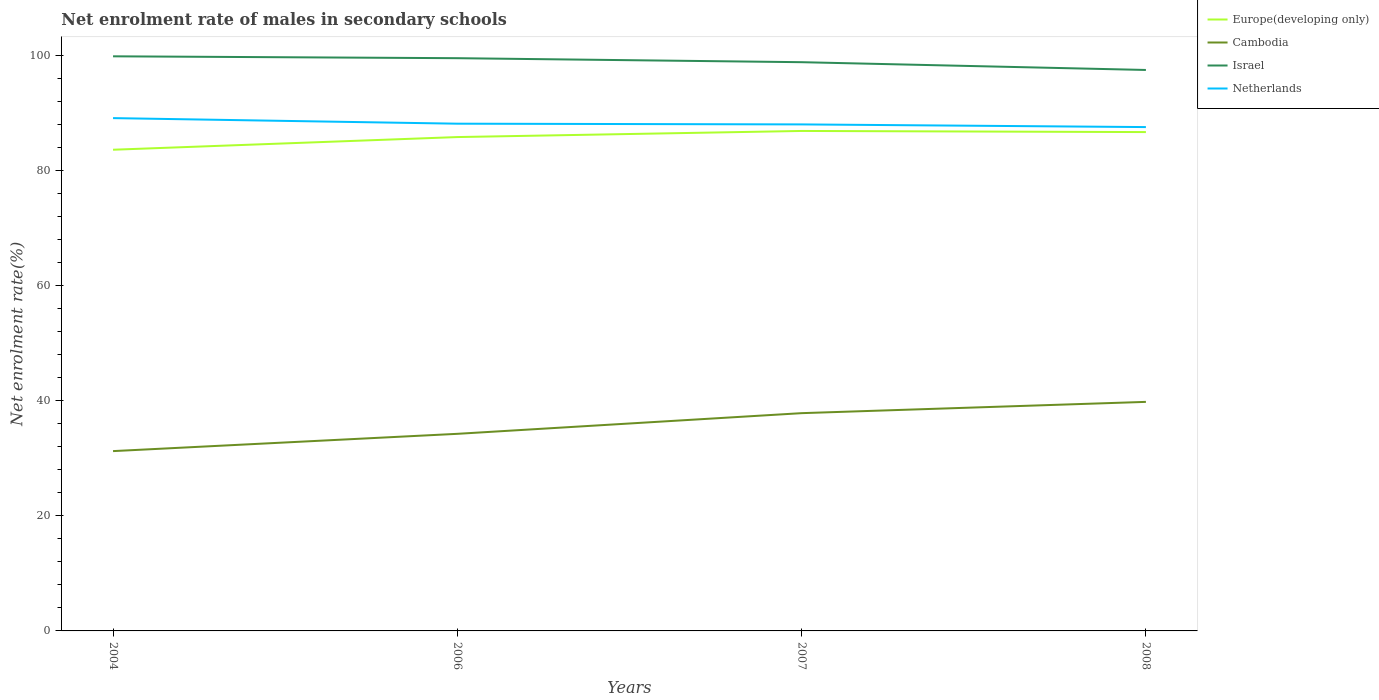How many different coloured lines are there?
Give a very brief answer. 4. Does the line corresponding to Israel intersect with the line corresponding to Europe(developing only)?
Your response must be concise. No. Is the number of lines equal to the number of legend labels?
Give a very brief answer. Yes. Across all years, what is the maximum net enrolment rate of males in secondary schools in Cambodia?
Your answer should be very brief. 31.24. In which year was the net enrolment rate of males in secondary schools in Netherlands maximum?
Offer a very short reply. 2008. What is the total net enrolment rate of males in secondary schools in Europe(developing only) in the graph?
Ensure brevity in your answer.  -1.06. What is the difference between the highest and the second highest net enrolment rate of males in secondary schools in Cambodia?
Keep it short and to the point. 8.55. Is the net enrolment rate of males in secondary schools in Europe(developing only) strictly greater than the net enrolment rate of males in secondary schools in Israel over the years?
Give a very brief answer. Yes. How many lines are there?
Keep it short and to the point. 4. How many years are there in the graph?
Offer a very short reply. 4. What is the difference between two consecutive major ticks on the Y-axis?
Offer a very short reply. 20. Are the values on the major ticks of Y-axis written in scientific E-notation?
Your answer should be compact. No. Does the graph contain grids?
Offer a terse response. No. Where does the legend appear in the graph?
Your answer should be very brief. Top right. How many legend labels are there?
Offer a terse response. 4. How are the legend labels stacked?
Provide a succinct answer. Vertical. What is the title of the graph?
Provide a succinct answer. Net enrolment rate of males in secondary schools. Does "Northern Mariana Islands" appear as one of the legend labels in the graph?
Your response must be concise. No. What is the label or title of the X-axis?
Provide a succinct answer. Years. What is the label or title of the Y-axis?
Your response must be concise. Net enrolment rate(%). What is the Net enrolment rate(%) of Europe(developing only) in 2004?
Make the answer very short. 83.59. What is the Net enrolment rate(%) of Cambodia in 2004?
Make the answer very short. 31.24. What is the Net enrolment rate(%) in Israel in 2004?
Your answer should be compact. 99.82. What is the Net enrolment rate(%) of Netherlands in 2004?
Your response must be concise. 89.09. What is the Net enrolment rate(%) of Europe(developing only) in 2006?
Your answer should be compact. 85.79. What is the Net enrolment rate(%) of Cambodia in 2006?
Your answer should be very brief. 34.24. What is the Net enrolment rate(%) in Israel in 2006?
Keep it short and to the point. 99.5. What is the Net enrolment rate(%) in Netherlands in 2006?
Your answer should be very brief. 88.12. What is the Net enrolment rate(%) of Europe(developing only) in 2007?
Give a very brief answer. 86.86. What is the Net enrolment rate(%) of Cambodia in 2007?
Offer a very short reply. 37.83. What is the Net enrolment rate(%) of Israel in 2007?
Make the answer very short. 98.8. What is the Net enrolment rate(%) in Netherlands in 2007?
Ensure brevity in your answer.  87.99. What is the Net enrolment rate(%) in Europe(developing only) in 2008?
Keep it short and to the point. 86.66. What is the Net enrolment rate(%) in Cambodia in 2008?
Give a very brief answer. 39.79. What is the Net enrolment rate(%) of Israel in 2008?
Provide a succinct answer. 97.45. What is the Net enrolment rate(%) of Netherlands in 2008?
Your answer should be very brief. 87.53. Across all years, what is the maximum Net enrolment rate(%) in Europe(developing only)?
Provide a short and direct response. 86.86. Across all years, what is the maximum Net enrolment rate(%) in Cambodia?
Make the answer very short. 39.79. Across all years, what is the maximum Net enrolment rate(%) in Israel?
Your answer should be very brief. 99.82. Across all years, what is the maximum Net enrolment rate(%) in Netherlands?
Your answer should be compact. 89.09. Across all years, what is the minimum Net enrolment rate(%) in Europe(developing only)?
Make the answer very short. 83.59. Across all years, what is the minimum Net enrolment rate(%) of Cambodia?
Your answer should be compact. 31.24. Across all years, what is the minimum Net enrolment rate(%) in Israel?
Your answer should be very brief. 97.45. Across all years, what is the minimum Net enrolment rate(%) of Netherlands?
Offer a very short reply. 87.53. What is the total Net enrolment rate(%) of Europe(developing only) in the graph?
Your response must be concise. 342.9. What is the total Net enrolment rate(%) in Cambodia in the graph?
Your answer should be very brief. 143.1. What is the total Net enrolment rate(%) of Israel in the graph?
Keep it short and to the point. 395.57. What is the total Net enrolment rate(%) in Netherlands in the graph?
Your answer should be very brief. 352.73. What is the difference between the Net enrolment rate(%) in Europe(developing only) in 2004 and that in 2006?
Give a very brief answer. -2.2. What is the difference between the Net enrolment rate(%) of Cambodia in 2004 and that in 2006?
Your answer should be compact. -3. What is the difference between the Net enrolment rate(%) in Israel in 2004 and that in 2006?
Your response must be concise. 0.33. What is the difference between the Net enrolment rate(%) of Netherlands in 2004 and that in 2006?
Ensure brevity in your answer.  0.97. What is the difference between the Net enrolment rate(%) in Europe(developing only) in 2004 and that in 2007?
Make the answer very short. -3.26. What is the difference between the Net enrolment rate(%) in Cambodia in 2004 and that in 2007?
Provide a succinct answer. -6.59. What is the difference between the Net enrolment rate(%) in Israel in 2004 and that in 2007?
Give a very brief answer. 1.02. What is the difference between the Net enrolment rate(%) of Netherlands in 2004 and that in 2007?
Offer a very short reply. 1.09. What is the difference between the Net enrolment rate(%) of Europe(developing only) in 2004 and that in 2008?
Offer a terse response. -3.07. What is the difference between the Net enrolment rate(%) in Cambodia in 2004 and that in 2008?
Your answer should be very brief. -8.55. What is the difference between the Net enrolment rate(%) of Israel in 2004 and that in 2008?
Offer a terse response. 2.37. What is the difference between the Net enrolment rate(%) of Netherlands in 2004 and that in 2008?
Keep it short and to the point. 1.56. What is the difference between the Net enrolment rate(%) in Europe(developing only) in 2006 and that in 2007?
Give a very brief answer. -1.06. What is the difference between the Net enrolment rate(%) of Cambodia in 2006 and that in 2007?
Offer a very short reply. -3.59. What is the difference between the Net enrolment rate(%) in Israel in 2006 and that in 2007?
Your answer should be very brief. 0.7. What is the difference between the Net enrolment rate(%) of Netherlands in 2006 and that in 2007?
Your response must be concise. 0.13. What is the difference between the Net enrolment rate(%) of Europe(developing only) in 2006 and that in 2008?
Provide a succinct answer. -0.86. What is the difference between the Net enrolment rate(%) of Cambodia in 2006 and that in 2008?
Your answer should be very brief. -5.55. What is the difference between the Net enrolment rate(%) in Israel in 2006 and that in 2008?
Make the answer very short. 2.05. What is the difference between the Net enrolment rate(%) in Netherlands in 2006 and that in 2008?
Make the answer very short. 0.59. What is the difference between the Net enrolment rate(%) in Europe(developing only) in 2007 and that in 2008?
Make the answer very short. 0.2. What is the difference between the Net enrolment rate(%) in Cambodia in 2007 and that in 2008?
Your answer should be compact. -1.96. What is the difference between the Net enrolment rate(%) of Israel in 2007 and that in 2008?
Your answer should be compact. 1.35. What is the difference between the Net enrolment rate(%) in Netherlands in 2007 and that in 2008?
Provide a succinct answer. 0.46. What is the difference between the Net enrolment rate(%) in Europe(developing only) in 2004 and the Net enrolment rate(%) in Cambodia in 2006?
Your answer should be compact. 49.35. What is the difference between the Net enrolment rate(%) of Europe(developing only) in 2004 and the Net enrolment rate(%) of Israel in 2006?
Your answer should be compact. -15.9. What is the difference between the Net enrolment rate(%) in Europe(developing only) in 2004 and the Net enrolment rate(%) in Netherlands in 2006?
Provide a succinct answer. -4.53. What is the difference between the Net enrolment rate(%) in Cambodia in 2004 and the Net enrolment rate(%) in Israel in 2006?
Your response must be concise. -68.26. What is the difference between the Net enrolment rate(%) of Cambodia in 2004 and the Net enrolment rate(%) of Netherlands in 2006?
Offer a terse response. -56.88. What is the difference between the Net enrolment rate(%) of Israel in 2004 and the Net enrolment rate(%) of Netherlands in 2006?
Provide a short and direct response. 11.7. What is the difference between the Net enrolment rate(%) in Europe(developing only) in 2004 and the Net enrolment rate(%) in Cambodia in 2007?
Your response must be concise. 45.76. What is the difference between the Net enrolment rate(%) of Europe(developing only) in 2004 and the Net enrolment rate(%) of Israel in 2007?
Provide a short and direct response. -15.21. What is the difference between the Net enrolment rate(%) in Cambodia in 2004 and the Net enrolment rate(%) in Israel in 2007?
Make the answer very short. -67.56. What is the difference between the Net enrolment rate(%) of Cambodia in 2004 and the Net enrolment rate(%) of Netherlands in 2007?
Your answer should be compact. -56.75. What is the difference between the Net enrolment rate(%) in Israel in 2004 and the Net enrolment rate(%) in Netherlands in 2007?
Offer a terse response. 11.83. What is the difference between the Net enrolment rate(%) in Europe(developing only) in 2004 and the Net enrolment rate(%) in Cambodia in 2008?
Give a very brief answer. 43.8. What is the difference between the Net enrolment rate(%) of Europe(developing only) in 2004 and the Net enrolment rate(%) of Israel in 2008?
Give a very brief answer. -13.86. What is the difference between the Net enrolment rate(%) in Europe(developing only) in 2004 and the Net enrolment rate(%) in Netherlands in 2008?
Offer a terse response. -3.94. What is the difference between the Net enrolment rate(%) in Cambodia in 2004 and the Net enrolment rate(%) in Israel in 2008?
Keep it short and to the point. -66.21. What is the difference between the Net enrolment rate(%) in Cambodia in 2004 and the Net enrolment rate(%) in Netherlands in 2008?
Give a very brief answer. -56.29. What is the difference between the Net enrolment rate(%) in Israel in 2004 and the Net enrolment rate(%) in Netherlands in 2008?
Offer a terse response. 12.29. What is the difference between the Net enrolment rate(%) of Europe(developing only) in 2006 and the Net enrolment rate(%) of Cambodia in 2007?
Offer a terse response. 47.96. What is the difference between the Net enrolment rate(%) of Europe(developing only) in 2006 and the Net enrolment rate(%) of Israel in 2007?
Ensure brevity in your answer.  -13.01. What is the difference between the Net enrolment rate(%) of Europe(developing only) in 2006 and the Net enrolment rate(%) of Netherlands in 2007?
Provide a short and direct response. -2.2. What is the difference between the Net enrolment rate(%) of Cambodia in 2006 and the Net enrolment rate(%) of Israel in 2007?
Provide a short and direct response. -64.56. What is the difference between the Net enrolment rate(%) of Cambodia in 2006 and the Net enrolment rate(%) of Netherlands in 2007?
Ensure brevity in your answer.  -53.75. What is the difference between the Net enrolment rate(%) of Israel in 2006 and the Net enrolment rate(%) of Netherlands in 2007?
Give a very brief answer. 11.5. What is the difference between the Net enrolment rate(%) in Europe(developing only) in 2006 and the Net enrolment rate(%) in Cambodia in 2008?
Provide a succinct answer. 46.01. What is the difference between the Net enrolment rate(%) of Europe(developing only) in 2006 and the Net enrolment rate(%) of Israel in 2008?
Your answer should be compact. -11.66. What is the difference between the Net enrolment rate(%) of Europe(developing only) in 2006 and the Net enrolment rate(%) of Netherlands in 2008?
Your answer should be very brief. -1.73. What is the difference between the Net enrolment rate(%) in Cambodia in 2006 and the Net enrolment rate(%) in Israel in 2008?
Your answer should be very brief. -63.21. What is the difference between the Net enrolment rate(%) of Cambodia in 2006 and the Net enrolment rate(%) of Netherlands in 2008?
Keep it short and to the point. -53.29. What is the difference between the Net enrolment rate(%) in Israel in 2006 and the Net enrolment rate(%) in Netherlands in 2008?
Make the answer very short. 11.97. What is the difference between the Net enrolment rate(%) in Europe(developing only) in 2007 and the Net enrolment rate(%) in Cambodia in 2008?
Provide a succinct answer. 47.07. What is the difference between the Net enrolment rate(%) in Europe(developing only) in 2007 and the Net enrolment rate(%) in Israel in 2008?
Provide a succinct answer. -10.59. What is the difference between the Net enrolment rate(%) in Europe(developing only) in 2007 and the Net enrolment rate(%) in Netherlands in 2008?
Keep it short and to the point. -0.67. What is the difference between the Net enrolment rate(%) in Cambodia in 2007 and the Net enrolment rate(%) in Israel in 2008?
Offer a very short reply. -59.62. What is the difference between the Net enrolment rate(%) in Cambodia in 2007 and the Net enrolment rate(%) in Netherlands in 2008?
Your response must be concise. -49.7. What is the difference between the Net enrolment rate(%) of Israel in 2007 and the Net enrolment rate(%) of Netherlands in 2008?
Make the answer very short. 11.27. What is the average Net enrolment rate(%) of Europe(developing only) per year?
Your answer should be very brief. 85.73. What is the average Net enrolment rate(%) in Cambodia per year?
Your answer should be very brief. 35.77. What is the average Net enrolment rate(%) in Israel per year?
Provide a succinct answer. 98.89. What is the average Net enrolment rate(%) of Netherlands per year?
Your answer should be compact. 88.18. In the year 2004, what is the difference between the Net enrolment rate(%) in Europe(developing only) and Net enrolment rate(%) in Cambodia?
Your answer should be very brief. 52.35. In the year 2004, what is the difference between the Net enrolment rate(%) of Europe(developing only) and Net enrolment rate(%) of Israel?
Your answer should be very brief. -16.23. In the year 2004, what is the difference between the Net enrolment rate(%) in Europe(developing only) and Net enrolment rate(%) in Netherlands?
Ensure brevity in your answer.  -5.49. In the year 2004, what is the difference between the Net enrolment rate(%) in Cambodia and Net enrolment rate(%) in Israel?
Provide a short and direct response. -68.58. In the year 2004, what is the difference between the Net enrolment rate(%) of Cambodia and Net enrolment rate(%) of Netherlands?
Give a very brief answer. -57.85. In the year 2004, what is the difference between the Net enrolment rate(%) of Israel and Net enrolment rate(%) of Netherlands?
Your answer should be compact. 10.74. In the year 2006, what is the difference between the Net enrolment rate(%) of Europe(developing only) and Net enrolment rate(%) of Cambodia?
Provide a short and direct response. 51.56. In the year 2006, what is the difference between the Net enrolment rate(%) of Europe(developing only) and Net enrolment rate(%) of Israel?
Ensure brevity in your answer.  -13.7. In the year 2006, what is the difference between the Net enrolment rate(%) in Europe(developing only) and Net enrolment rate(%) in Netherlands?
Give a very brief answer. -2.32. In the year 2006, what is the difference between the Net enrolment rate(%) in Cambodia and Net enrolment rate(%) in Israel?
Give a very brief answer. -65.26. In the year 2006, what is the difference between the Net enrolment rate(%) in Cambodia and Net enrolment rate(%) in Netherlands?
Provide a short and direct response. -53.88. In the year 2006, what is the difference between the Net enrolment rate(%) in Israel and Net enrolment rate(%) in Netherlands?
Provide a short and direct response. 11.38. In the year 2007, what is the difference between the Net enrolment rate(%) in Europe(developing only) and Net enrolment rate(%) in Cambodia?
Make the answer very short. 49.02. In the year 2007, what is the difference between the Net enrolment rate(%) in Europe(developing only) and Net enrolment rate(%) in Israel?
Provide a succinct answer. -11.94. In the year 2007, what is the difference between the Net enrolment rate(%) in Europe(developing only) and Net enrolment rate(%) in Netherlands?
Ensure brevity in your answer.  -1.14. In the year 2007, what is the difference between the Net enrolment rate(%) of Cambodia and Net enrolment rate(%) of Israel?
Make the answer very short. -60.97. In the year 2007, what is the difference between the Net enrolment rate(%) in Cambodia and Net enrolment rate(%) in Netherlands?
Offer a terse response. -50.16. In the year 2007, what is the difference between the Net enrolment rate(%) in Israel and Net enrolment rate(%) in Netherlands?
Offer a terse response. 10.81. In the year 2008, what is the difference between the Net enrolment rate(%) in Europe(developing only) and Net enrolment rate(%) in Cambodia?
Offer a very short reply. 46.87. In the year 2008, what is the difference between the Net enrolment rate(%) in Europe(developing only) and Net enrolment rate(%) in Israel?
Provide a short and direct response. -10.79. In the year 2008, what is the difference between the Net enrolment rate(%) in Europe(developing only) and Net enrolment rate(%) in Netherlands?
Provide a short and direct response. -0.87. In the year 2008, what is the difference between the Net enrolment rate(%) of Cambodia and Net enrolment rate(%) of Israel?
Ensure brevity in your answer.  -57.66. In the year 2008, what is the difference between the Net enrolment rate(%) in Cambodia and Net enrolment rate(%) in Netherlands?
Your answer should be compact. -47.74. In the year 2008, what is the difference between the Net enrolment rate(%) of Israel and Net enrolment rate(%) of Netherlands?
Keep it short and to the point. 9.92. What is the ratio of the Net enrolment rate(%) of Europe(developing only) in 2004 to that in 2006?
Keep it short and to the point. 0.97. What is the ratio of the Net enrolment rate(%) in Cambodia in 2004 to that in 2006?
Ensure brevity in your answer.  0.91. What is the ratio of the Net enrolment rate(%) in Netherlands in 2004 to that in 2006?
Give a very brief answer. 1.01. What is the ratio of the Net enrolment rate(%) in Europe(developing only) in 2004 to that in 2007?
Ensure brevity in your answer.  0.96. What is the ratio of the Net enrolment rate(%) of Cambodia in 2004 to that in 2007?
Keep it short and to the point. 0.83. What is the ratio of the Net enrolment rate(%) of Israel in 2004 to that in 2007?
Make the answer very short. 1.01. What is the ratio of the Net enrolment rate(%) in Netherlands in 2004 to that in 2007?
Make the answer very short. 1.01. What is the ratio of the Net enrolment rate(%) of Europe(developing only) in 2004 to that in 2008?
Give a very brief answer. 0.96. What is the ratio of the Net enrolment rate(%) in Cambodia in 2004 to that in 2008?
Your answer should be very brief. 0.79. What is the ratio of the Net enrolment rate(%) in Israel in 2004 to that in 2008?
Offer a very short reply. 1.02. What is the ratio of the Net enrolment rate(%) of Netherlands in 2004 to that in 2008?
Ensure brevity in your answer.  1.02. What is the ratio of the Net enrolment rate(%) of Cambodia in 2006 to that in 2007?
Give a very brief answer. 0.91. What is the ratio of the Net enrolment rate(%) in Netherlands in 2006 to that in 2007?
Offer a terse response. 1. What is the ratio of the Net enrolment rate(%) in Europe(developing only) in 2006 to that in 2008?
Your answer should be compact. 0.99. What is the ratio of the Net enrolment rate(%) of Cambodia in 2006 to that in 2008?
Provide a succinct answer. 0.86. What is the ratio of the Net enrolment rate(%) of Israel in 2006 to that in 2008?
Your answer should be compact. 1.02. What is the ratio of the Net enrolment rate(%) of Cambodia in 2007 to that in 2008?
Ensure brevity in your answer.  0.95. What is the ratio of the Net enrolment rate(%) in Israel in 2007 to that in 2008?
Offer a very short reply. 1.01. What is the difference between the highest and the second highest Net enrolment rate(%) of Europe(developing only)?
Your response must be concise. 0.2. What is the difference between the highest and the second highest Net enrolment rate(%) of Cambodia?
Ensure brevity in your answer.  1.96. What is the difference between the highest and the second highest Net enrolment rate(%) of Israel?
Give a very brief answer. 0.33. What is the difference between the highest and the second highest Net enrolment rate(%) in Netherlands?
Your answer should be compact. 0.97. What is the difference between the highest and the lowest Net enrolment rate(%) of Europe(developing only)?
Give a very brief answer. 3.26. What is the difference between the highest and the lowest Net enrolment rate(%) in Cambodia?
Your response must be concise. 8.55. What is the difference between the highest and the lowest Net enrolment rate(%) in Israel?
Provide a short and direct response. 2.37. What is the difference between the highest and the lowest Net enrolment rate(%) of Netherlands?
Make the answer very short. 1.56. 